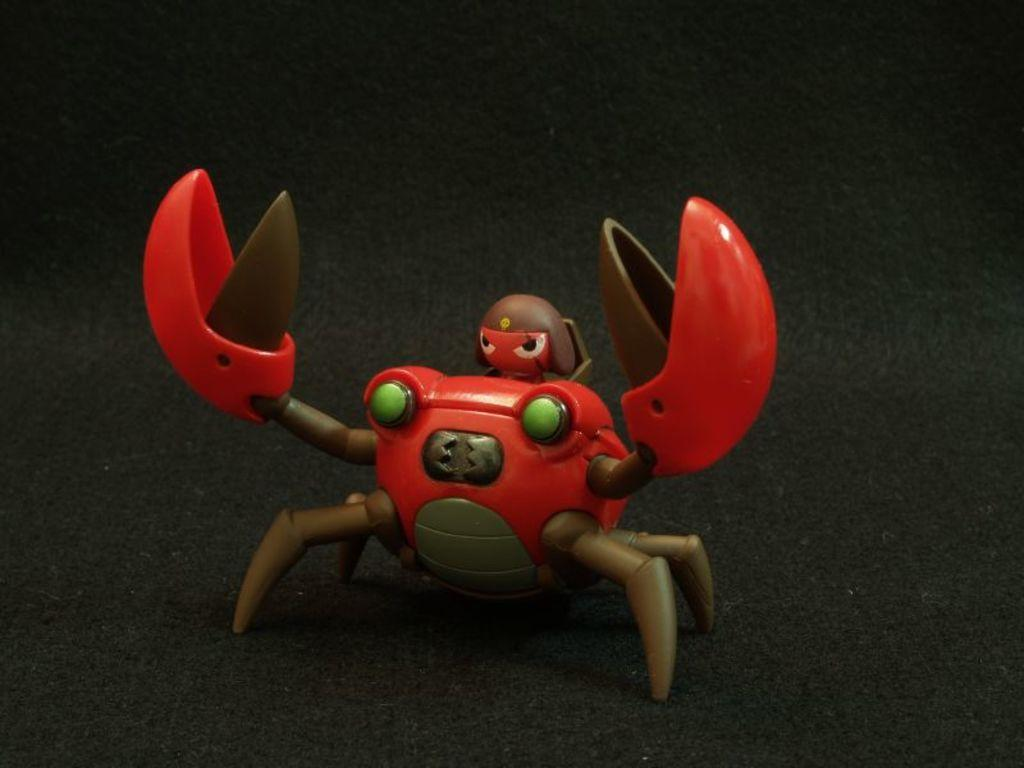What object is present in the image? There is a toy in the image. What is the color of the surface on which the toy is placed? The toy is on a black color surface. How many potatoes are visible in the image? There are no potatoes present in the image. What type of scene is depicted in the image? The image does not depict a scene; it features a toy on a black color surface. How many clocks can be seen in the image? There are no clocks present in the image. 